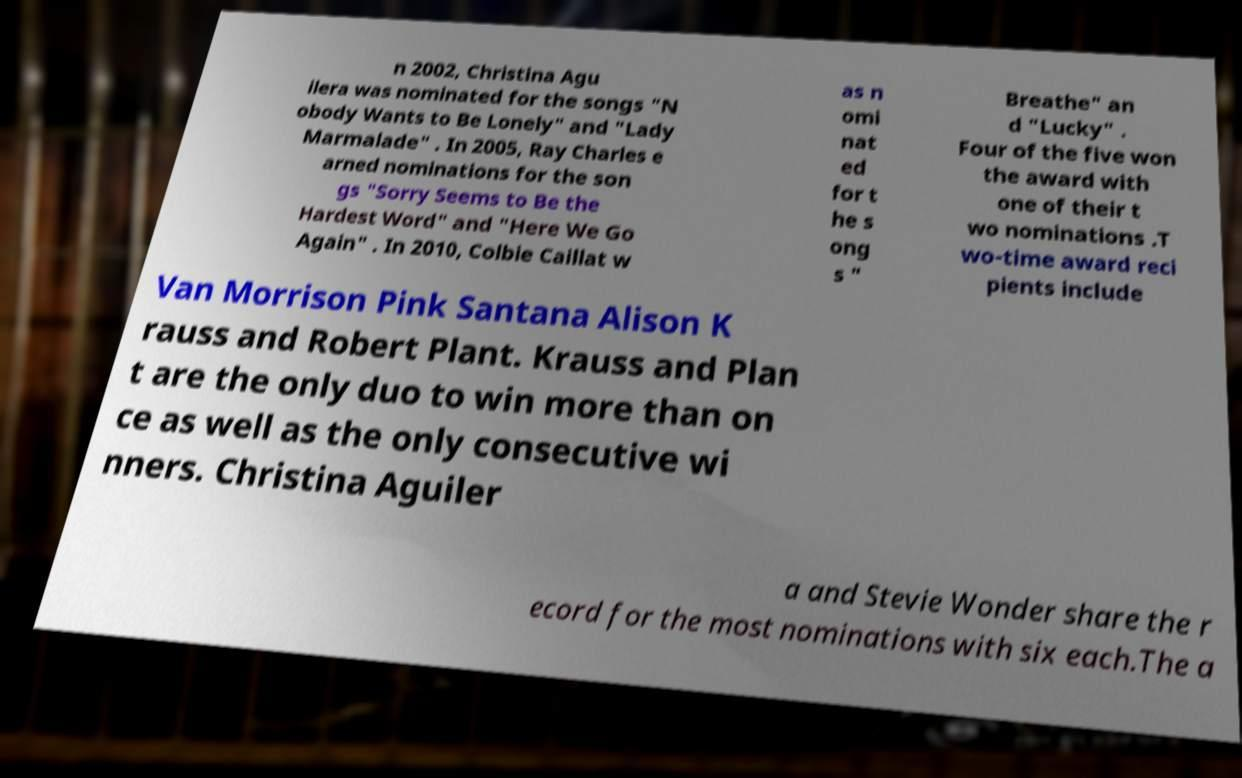I need the written content from this picture converted into text. Can you do that? n 2002, Christina Agu ilera was nominated for the songs "N obody Wants to Be Lonely" and "Lady Marmalade" . In 2005, Ray Charles e arned nominations for the son gs "Sorry Seems to Be the Hardest Word" and "Here We Go Again" . In 2010, Colbie Caillat w as n omi nat ed for t he s ong s " Breathe" an d "Lucky" . Four of the five won the award with one of their t wo nominations .T wo-time award reci pients include Van Morrison Pink Santana Alison K rauss and Robert Plant. Krauss and Plan t are the only duo to win more than on ce as well as the only consecutive wi nners. Christina Aguiler a and Stevie Wonder share the r ecord for the most nominations with six each.The a 